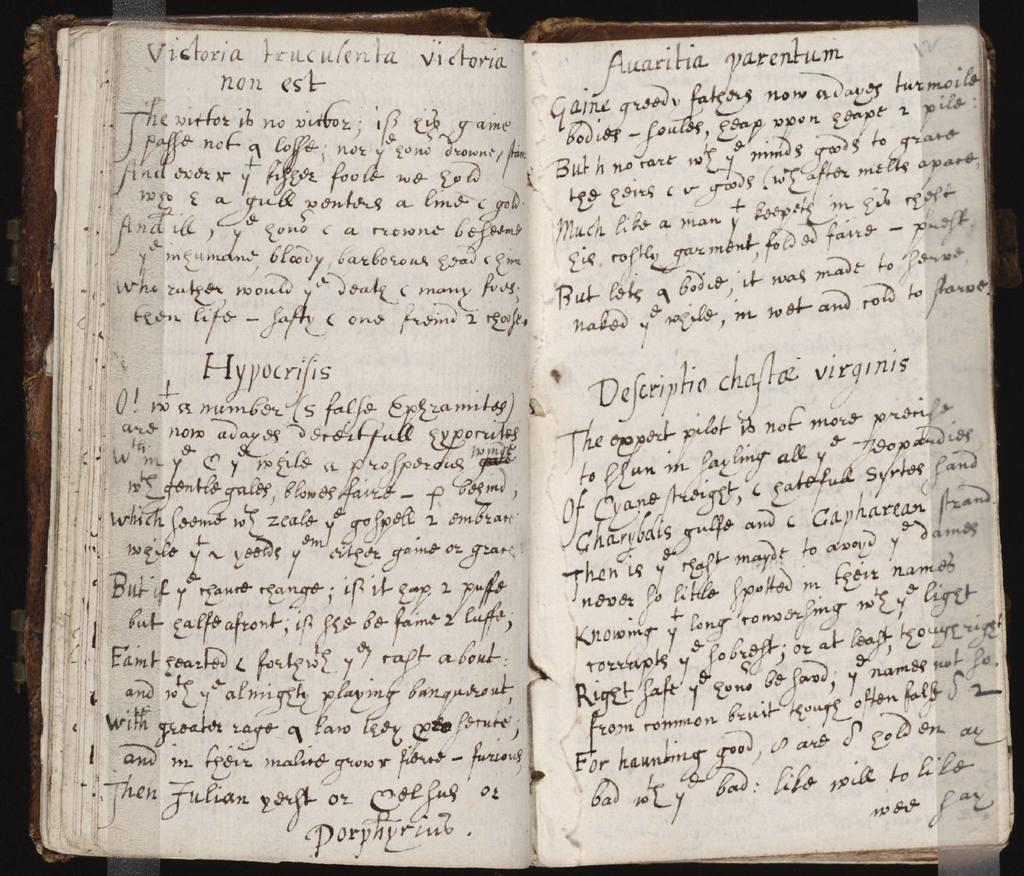<image>
Share a concise interpretation of the image provided. An old handwritten book in a non-English language. 